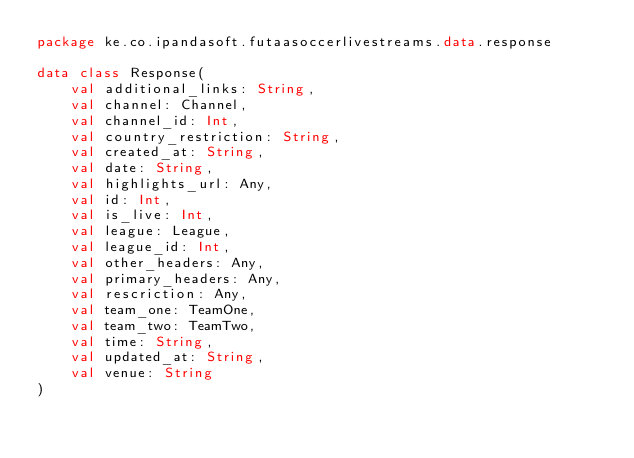Convert code to text. <code><loc_0><loc_0><loc_500><loc_500><_Kotlin_>package ke.co.ipandasoft.futaasoccerlivestreams.data.response

data class Response(
    val additional_links: String,
    val channel: Channel,
    val channel_id: Int,
    val country_restriction: String,
    val created_at: String,
    val date: String,
    val highlights_url: Any,
    val id: Int,
    val is_live: Int,
    val league: League,
    val league_id: Int,
    val other_headers: Any,
    val primary_headers: Any,
    val rescriction: Any,
    val team_one: TeamOne,
    val team_two: TeamTwo,
    val time: String,
    val updated_at: String,
    val venue: String
)</code> 